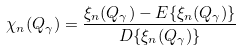Convert formula to latex. <formula><loc_0><loc_0><loc_500><loc_500>\chi _ { n } ( Q _ { \gamma } ) = \frac { \xi _ { n } ( Q _ { \gamma } ) - { E } \{ \xi _ { n } ( Q _ { \gamma } ) \} } { { D } \{ \xi _ { n } ( Q _ { \gamma } ) \} }</formula> 